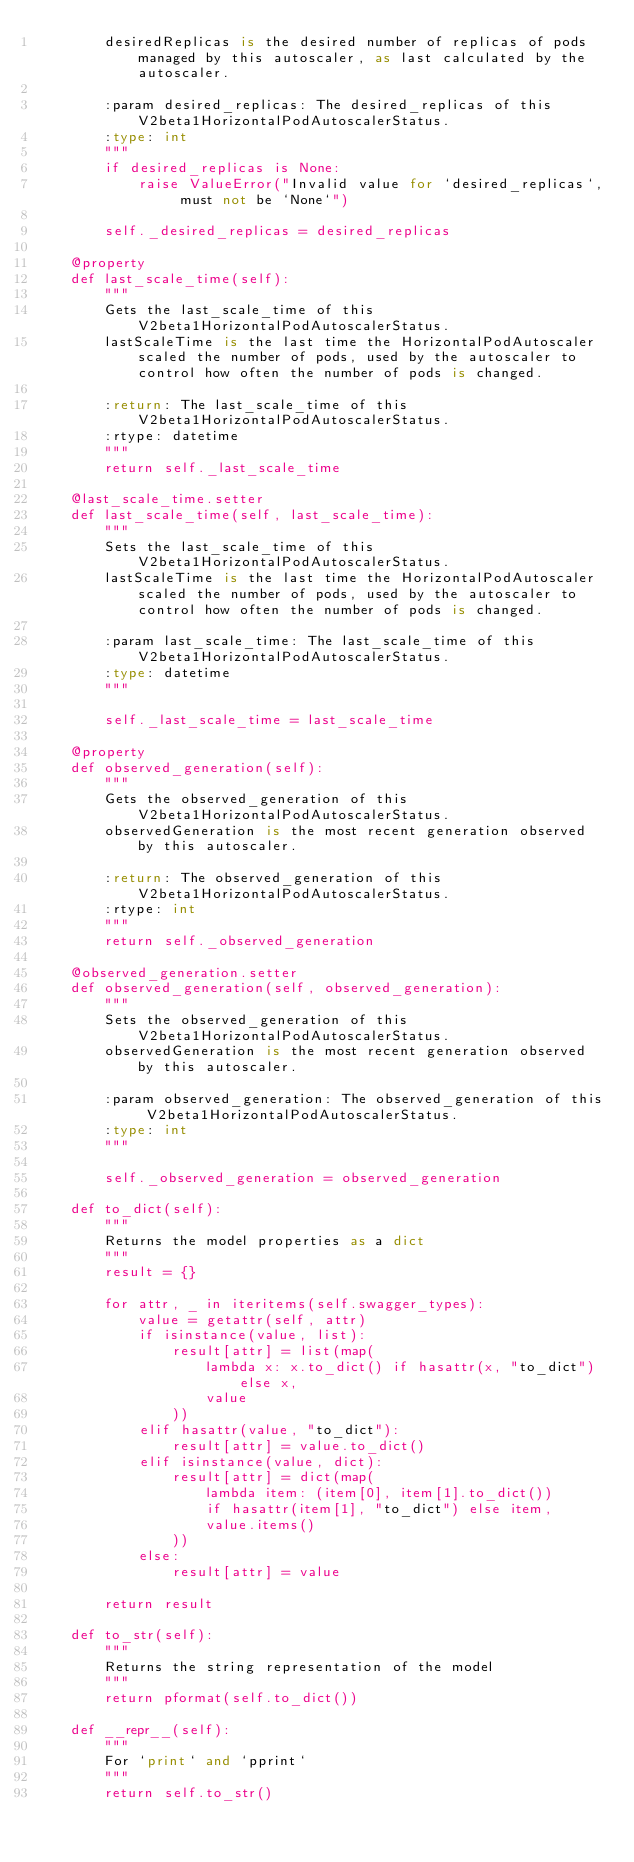<code> <loc_0><loc_0><loc_500><loc_500><_Python_>        desiredReplicas is the desired number of replicas of pods managed by this autoscaler, as last calculated by the autoscaler.

        :param desired_replicas: The desired_replicas of this V2beta1HorizontalPodAutoscalerStatus.
        :type: int
        """
        if desired_replicas is None:
            raise ValueError("Invalid value for `desired_replicas`, must not be `None`")

        self._desired_replicas = desired_replicas

    @property
    def last_scale_time(self):
        """
        Gets the last_scale_time of this V2beta1HorizontalPodAutoscalerStatus.
        lastScaleTime is the last time the HorizontalPodAutoscaler scaled the number of pods, used by the autoscaler to control how often the number of pods is changed.

        :return: The last_scale_time of this V2beta1HorizontalPodAutoscalerStatus.
        :rtype: datetime
        """
        return self._last_scale_time

    @last_scale_time.setter
    def last_scale_time(self, last_scale_time):
        """
        Sets the last_scale_time of this V2beta1HorizontalPodAutoscalerStatus.
        lastScaleTime is the last time the HorizontalPodAutoscaler scaled the number of pods, used by the autoscaler to control how often the number of pods is changed.

        :param last_scale_time: The last_scale_time of this V2beta1HorizontalPodAutoscalerStatus.
        :type: datetime
        """

        self._last_scale_time = last_scale_time

    @property
    def observed_generation(self):
        """
        Gets the observed_generation of this V2beta1HorizontalPodAutoscalerStatus.
        observedGeneration is the most recent generation observed by this autoscaler.

        :return: The observed_generation of this V2beta1HorizontalPodAutoscalerStatus.
        :rtype: int
        """
        return self._observed_generation

    @observed_generation.setter
    def observed_generation(self, observed_generation):
        """
        Sets the observed_generation of this V2beta1HorizontalPodAutoscalerStatus.
        observedGeneration is the most recent generation observed by this autoscaler.

        :param observed_generation: The observed_generation of this V2beta1HorizontalPodAutoscalerStatus.
        :type: int
        """

        self._observed_generation = observed_generation

    def to_dict(self):
        """
        Returns the model properties as a dict
        """
        result = {}

        for attr, _ in iteritems(self.swagger_types):
            value = getattr(self, attr)
            if isinstance(value, list):
                result[attr] = list(map(
                    lambda x: x.to_dict() if hasattr(x, "to_dict") else x,
                    value
                ))
            elif hasattr(value, "to_dict"):
                result[attr] = value.to_dict()
            elif isinstance(value, dict):
                result[attr] = dict(map(
                    lambda item: (item[0], item[1].to_dict())
                    if hasattr(item[1], "to_dict") else item,
                    value.items()
                ))
            else:
                result[attr] = value

        return result

    def to_str(self):
        """
        Returns the string representation of the model
        """
        return pformat(self.to_dict())

    def __repr__(self):
        """
        For `print` and `pprint`
        """
        return self.to_str()
</code> 